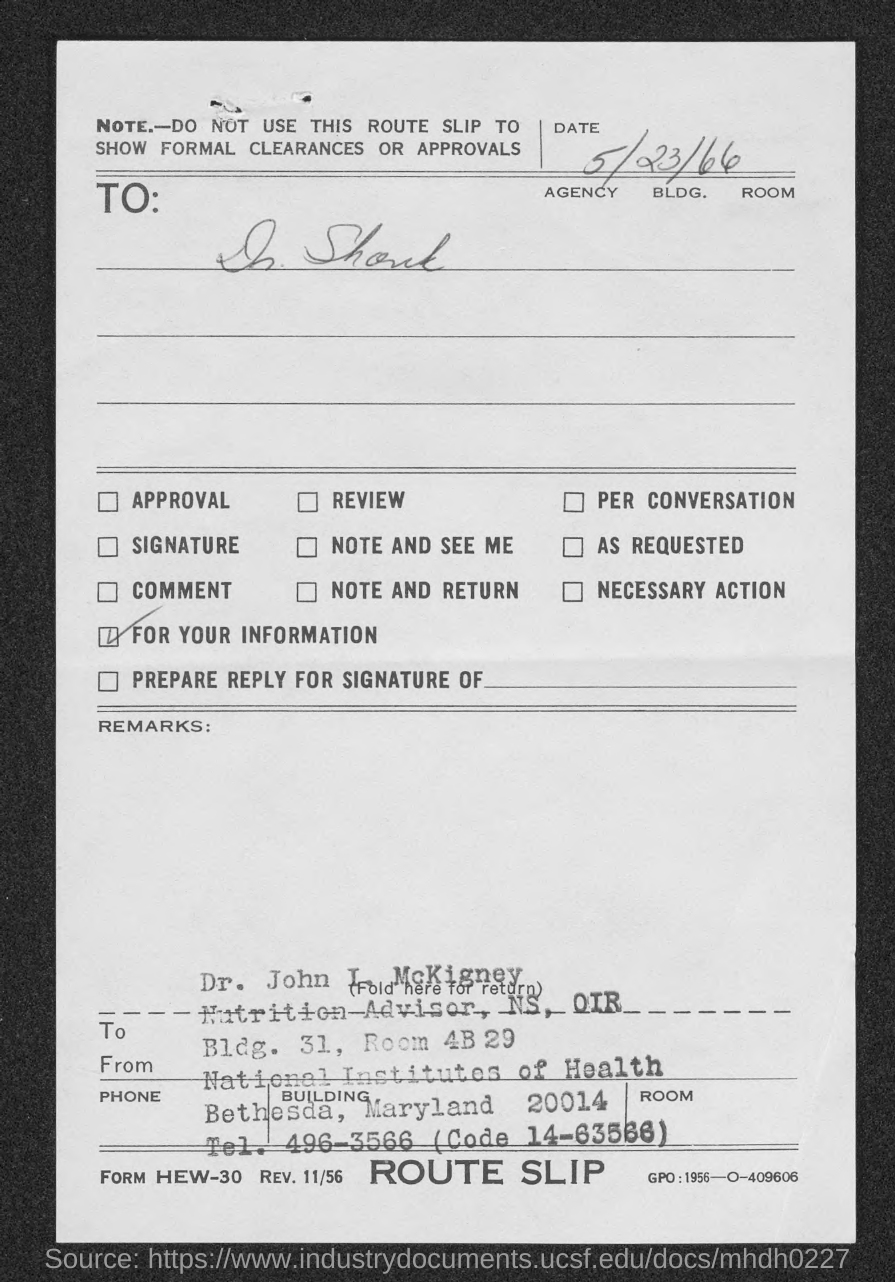Specify some key components in this picture. The date on the route slip is May 23, 1966. 